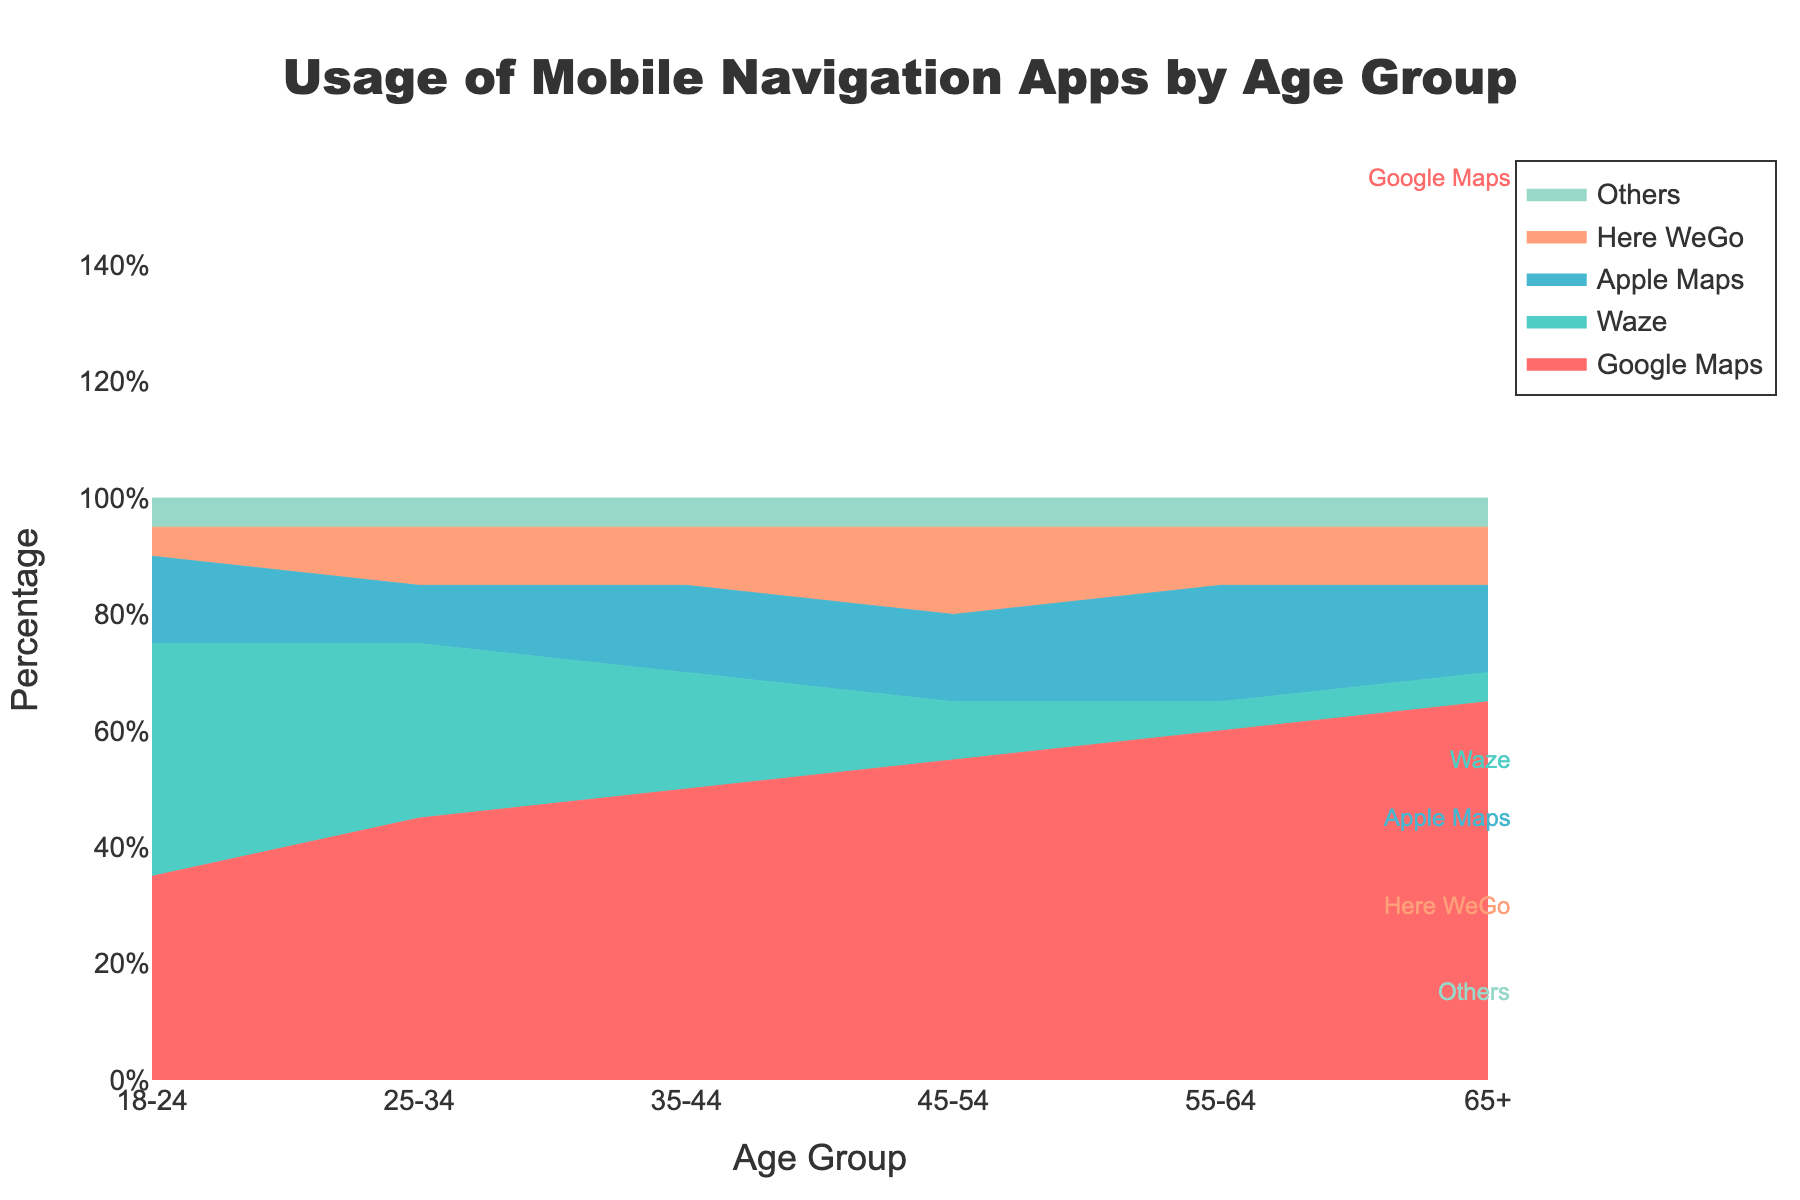What is the title of the chart? The title is usually found at the top of the chart and clearly indicates what the chart is about.
Answer: Usage of Mobile Navigation Apps by Age Group Which app has the highest usage percentage in the 18-24 age group? Looking at the stacked area segment for the 18-24 age group, we see which app occupies the largest portion of the stack.
Answer: Waze What is the total percentage of Google Maps users for the age group 55-64? Since Google Maps users are represented by a specific color band, locate this band for the age group 55-64 and read the percentage label.
Answer: 60% How does the usage of Google Maps compare between the age groups 25-34 and 45-54? Observe the percentage of the Google Maps segment in the 25-34 age group and compare it with the percentage in the 45-54 age group.
Answer: Higher in 45-54 What is the trend of Apple Maps usage across different age groups? Look at the area corresponding to Apple Maps and see how it changes as you move from the youngest to oldest age group.
Answer: Increases with age Which app has the most consistent usage percentage across all age groups? Compare the segments of each app to see which one maintains a nearly uniform width from age group to age group.
Answer: Others By how much does the usage of Waze drop from the age group 18-24 to 35-44? Identify the Waze segment for the age groups 18-24 and 35-44, then calculate the difference between the two percentages.
Answer: 20% What is the second most popular app in the 65+ age group? Examine the 65+ age group and identify the app segment that is second largest.
Answer: Apple Maps How does the usage of Here WeGo in the 45-54 age group compare to its usage in the 55-64 age group? Observe the Here WeGo segment for the 45-54 and 55-64 age groups and directly compare the two percentages.
Answer: Same in both (10%) What percentage of the 35-44 age group uses Here WeGo and Others combined? Locate the percentages for Here WeGo and Others in the 35-44 age group, then add them together.
Answer: 15% + 5% = 20% 